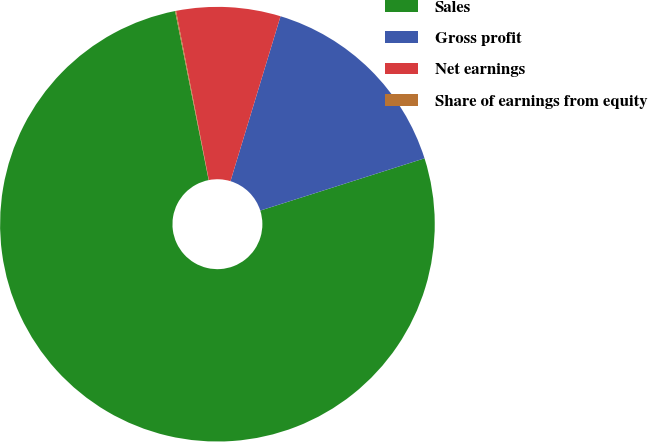Convert chart to OTSL. <chart><loc_0><loc_0><loc_500><loc_500><pie_chart><fcel>Sales<fcel>Gross profit<fcel>Net earnings<fcel>Share of earnings from equity<nl><fcel>76.78%<fcel>15.41%<fcel>7.74%<fcel>0.07%<nl></chart> 